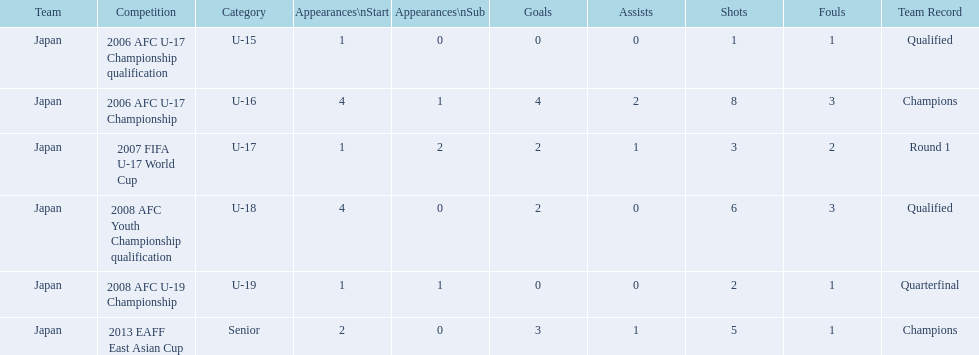How many appearances were there for each competition? 1, 4, 1, 4, 1, 2. How many goals were there for each competition? 0, 4, 2, 2, 0, 3. Which competition(s) has/have the most appearances? 2006 AFC U-17 Championship, 2008 AFC Youth Championship qualification. Which competition(s) has/have the most goals? 2006 AFC U-17 Championship. 